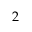Convert formula to latex. <formula><loc_0><loc_0><loc_500><loc_500>2</formula> 